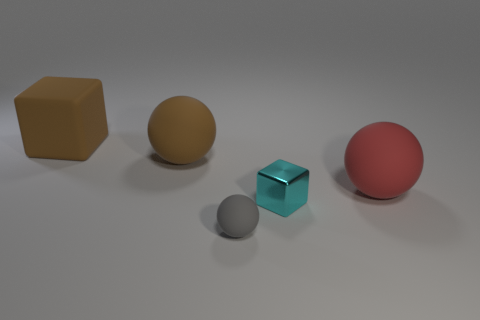Subtract all big brown rubber spheres. How many spheres are left? 2 Add 1 big green metallic spheres. How many objects exist? 6 Subtract all cubes. How many objects are left? 3 Subtract all green balls. Subtract all brown cubes. How many balls are left? 3 Add 4 big red objects. How many big red objects are left? 5 Add 3 cyan cubes. How many cyan cubes exist? 4 Subtract 0 cyan cylinders. How many objects are left? 5 Subtract all red spheres. Subtract all brown cubes. How many objects are left? 3 